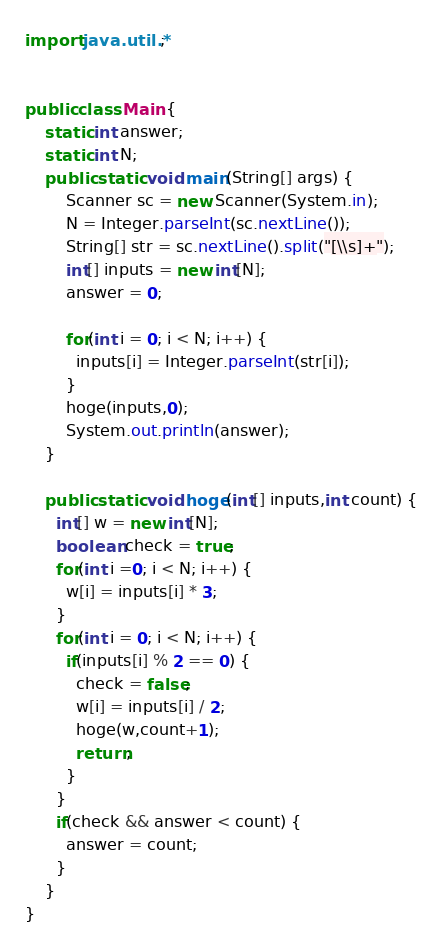Convert code to text. <code><loc_0><loc_0><loc_500><loc_500><_Java_>import java.util.*;


public class Main {
    static int answer;
    static int N;
    public static void main(String[] args) {
        Scanner sc = new Scanner(System.in);
        N = Integer.parseInt(sc.nextLine());
        String[] str = sc.nextLine().split("[\\s]+");
        int[] inputs = new int[N];
        answer = 0;

        for(int i = 0; i < N; i++) {
          inputs[i] = Integer.parseInt(str[i]);
        }
        hoge(inputs,0);
        System.out.println(answer);
    }

    public static void hoge(int[] inputs,int count) {
      int[] w = new int[N];
      boolean check = true;
      for(int i =0; i < N; i++) {
        w[i] = inputs[i] * 3;
      }
      for(int i = 0; i < N; i++) {
        if(inputs[i] % 2 == 0) {
          check = false;
          w[i] = inputs[i] / 2;
          hoge(w,count+1);
          return;
        }
      }
      if(check && answer < count) {
        answer = count;
      }
    }
}
</code> 